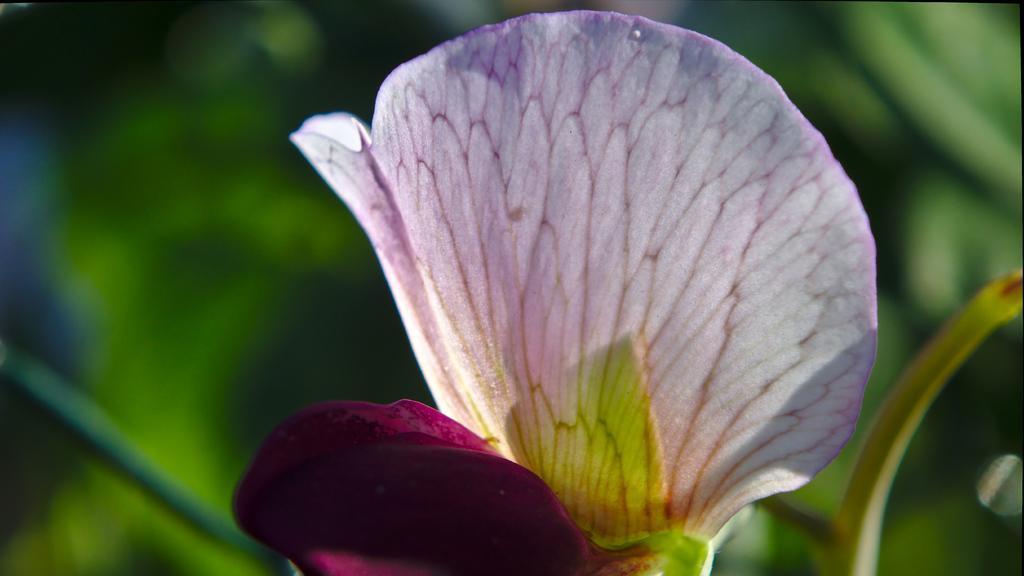Describe this image in one or two sentences. In this image in the foreground there is one flower, and in the background there are some plants. 